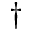<formula> <loc_0><loc_0><loc_500><loc_500>^ { \dag }</formula> 